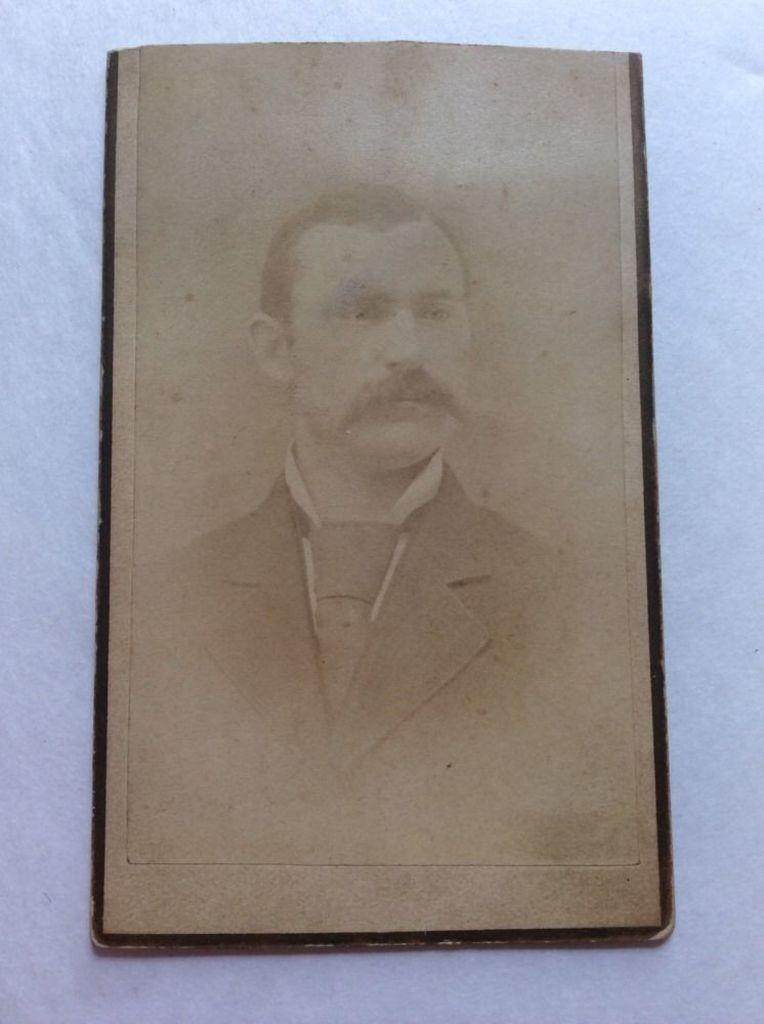What is the color scheme of the image? The image is black and white. Who is present in the image? There is a man in the image. What is the man wearing around his neck? The man is wearing a tie. What type of clothing is the man wearing on his upper body? The man is wearing a coat and a shirt. What type of plant can be seen growing in the mine in the image? There is no mine or plant present in the image; it features a man wearing a tie, coat, and shirt. 